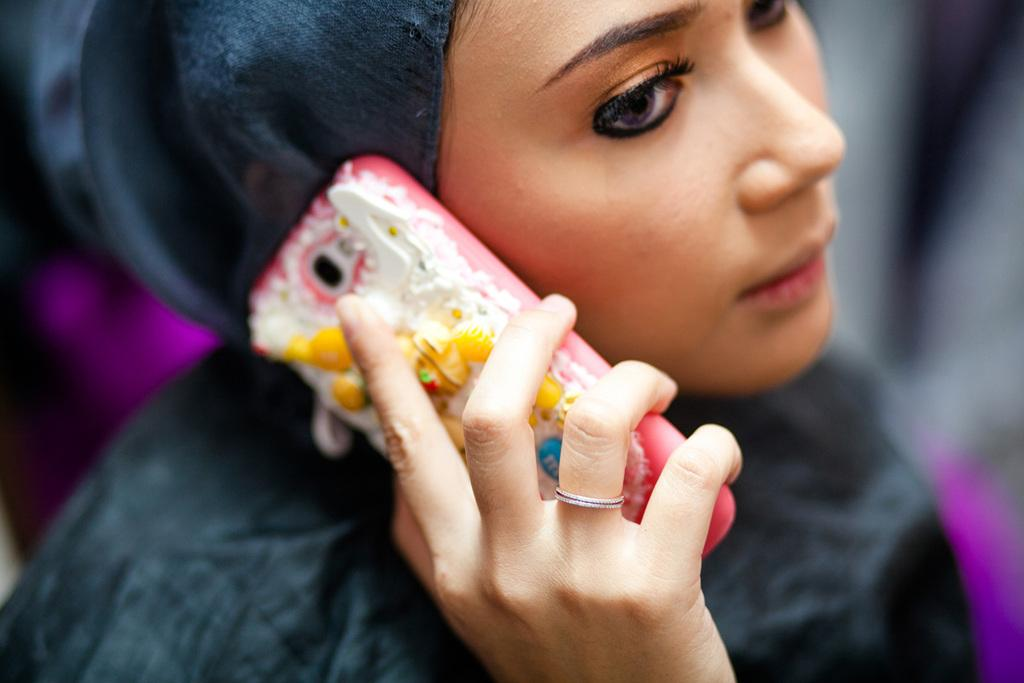Who is the main subject in the image? There is a girl in the image. What is the girl doing in the image? The girl is holding a mobile phone near her ear. What is the girl wearing in the image? The girl is wearing a black color dress. What type of plant is growing near the girl in the image? There is no plant visible near the girl in the image. What is the chance of the girl winning a lottery in the image? The image does not provide any information about the girl winning a lottery, so we cannot determine the chance of her winning. 